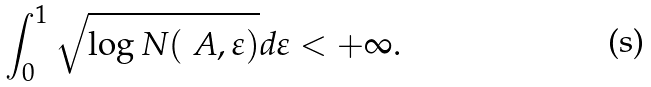Convert formula to latex. <formula><loc_0><loc_0><loc_500><loc_500>\int _ { 0 } ^ { 1 } \sqrt { \log N ( \ A , \varepsilon ) } d \varepsilon < + \infty .</formula> 